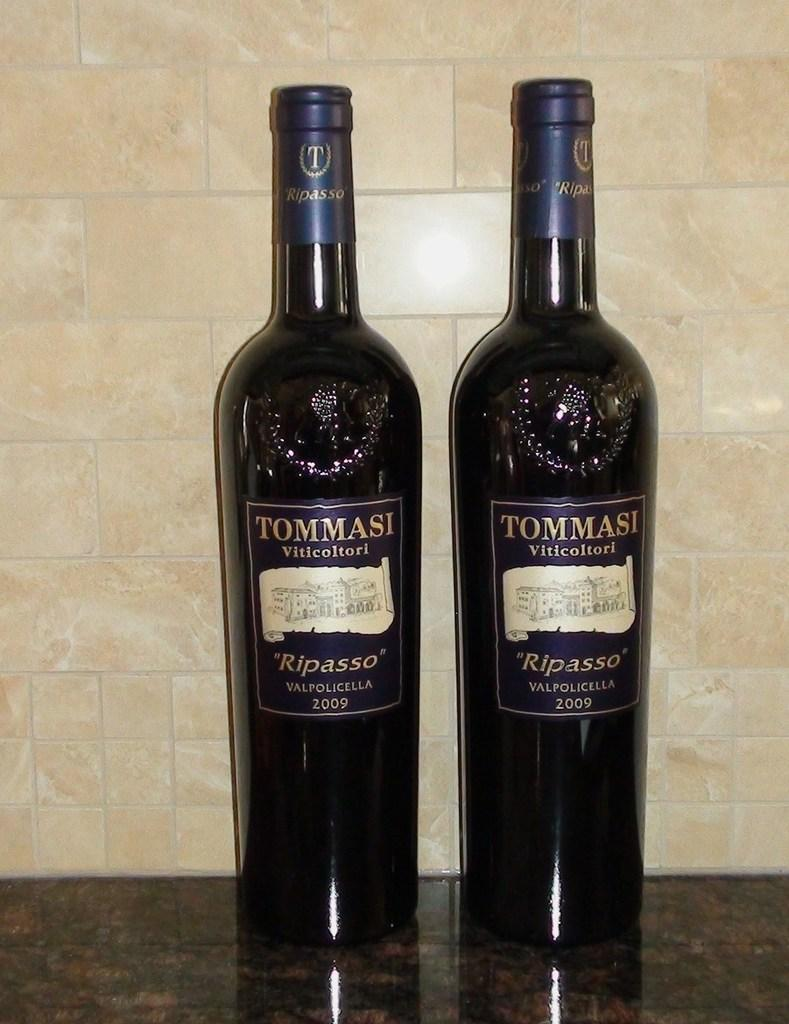Provide a one-sentence caption for the provided image. Tommasi Viticoltori ripasso valpolicella wine from 2009 on a counter. 